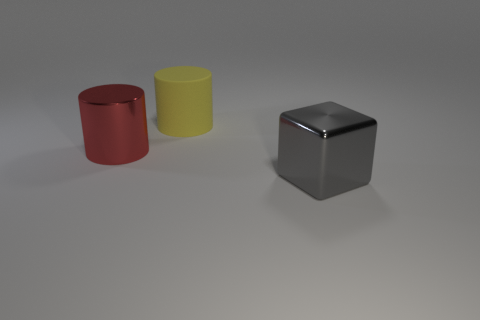How many blue metal cylinders are the same size as the red cylinder? There are no blue metal cylinders present in the image to compare with the red cylinder. The depicted objects include a red cylinder, a yellow cylinder, and a grey cube. 